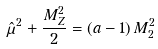Convert formula to latex. <formula><loc_0><loc_0><loc_500><loc_500>\hat { \mu } ^ { 2 } + \frac { M _ { Z } ^ { 2 } } { 2 } = \left ( a - 1 \right ) M _ { 2 } ^ { 2 }</formula> 